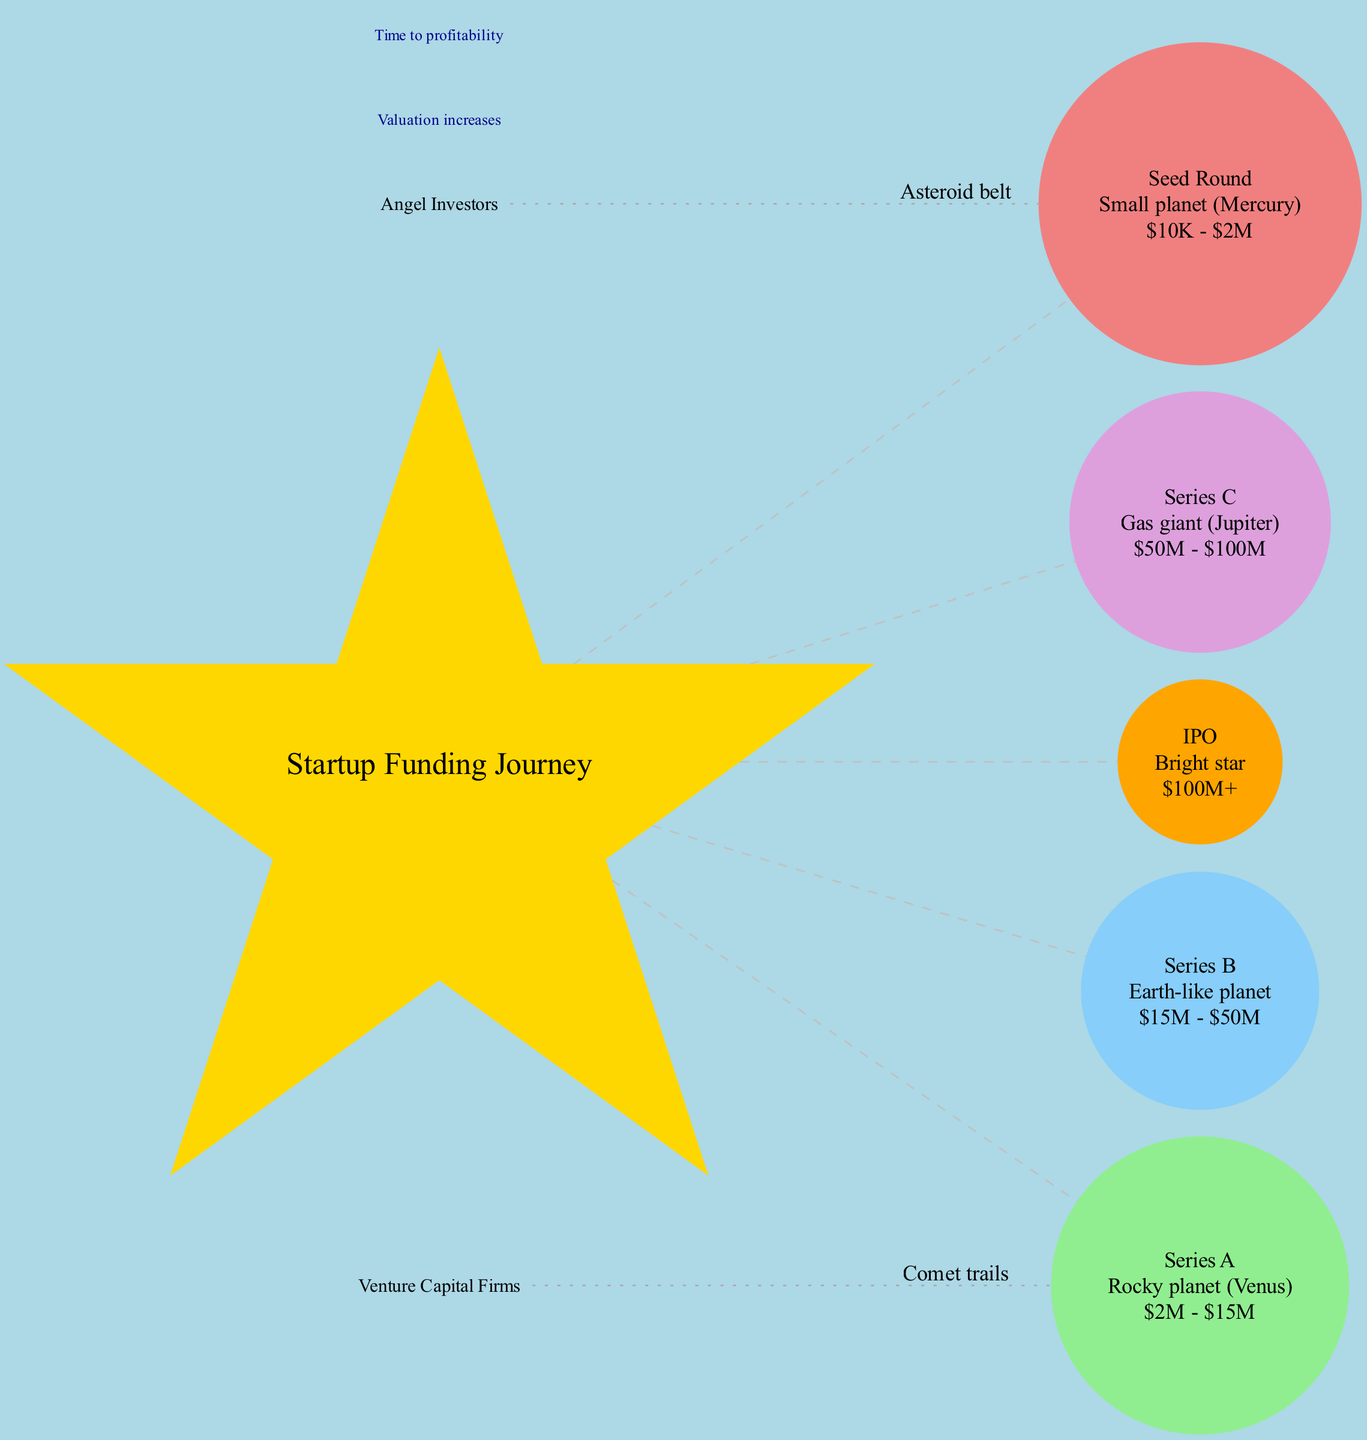What celestial body represents the Seed Round? The Seed Round is represented as a small planet, specifically Mercury. This information is displayed directly in the diagram's details of the celestial bodies.
Answer: Mercury What is the funding range for Series B? The funding range for Series B is stated in the diagram, and it shows a range from 15 million dollars to 50 million dollars, directly from the descriptive label associated with Series B.
Answer: 15 million dollars - 50 million dollars How many orbital paths are shown in the diagram? The diagram contains two orbital paths which are described as Angel Investors and Venture Capital Firms. This can be counted from the respective sections of the diagram discussing orbital paths.
Answer: 2 What description is given for the celestial body representing the IPO? The IPO is depicted as a bright star, and this description is provided in the details of the celestial bodies.
Answer: Bright star What is indicated by the annotations along the orbital paths? The annotations along the orbital paths indicate "Valuation increases," as stated in the specific annotations section within the diagram.
Answer: Valuation increases What is the relationship between Series C and its orbital path? Series C connects with the orbital path labeled as Venture Capital Firms; this relationship is visualized by the dotted line from the orbital path to Series C in the diagram, indicating that Series C is affected by venture capital investments.
Answer: Venture Capital Firms What celestial body corresponds to the funding range over 100 million dollars? The funding range over 100 million dollars corresponds to the IPO, as represented by the bright star in the diagram. This information is clearly marked in the celestial body descriptions.
Answer: IPO What is the radial distance from the center most likely highlighting? The radial distance from the center represents "Time to profitability," which can be concluded based on the respective annotations found in the diagram.
Answer: Time to profitability What planet does the Series A resemble? Series A resembles a rocky planet, specifically Venus, as specified in the diagram under the description for Series A.
Answer: Venus 